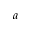Convert formula to latex. <formula><loc_0><loc_0><loc_500><loc_500>a</formula> 